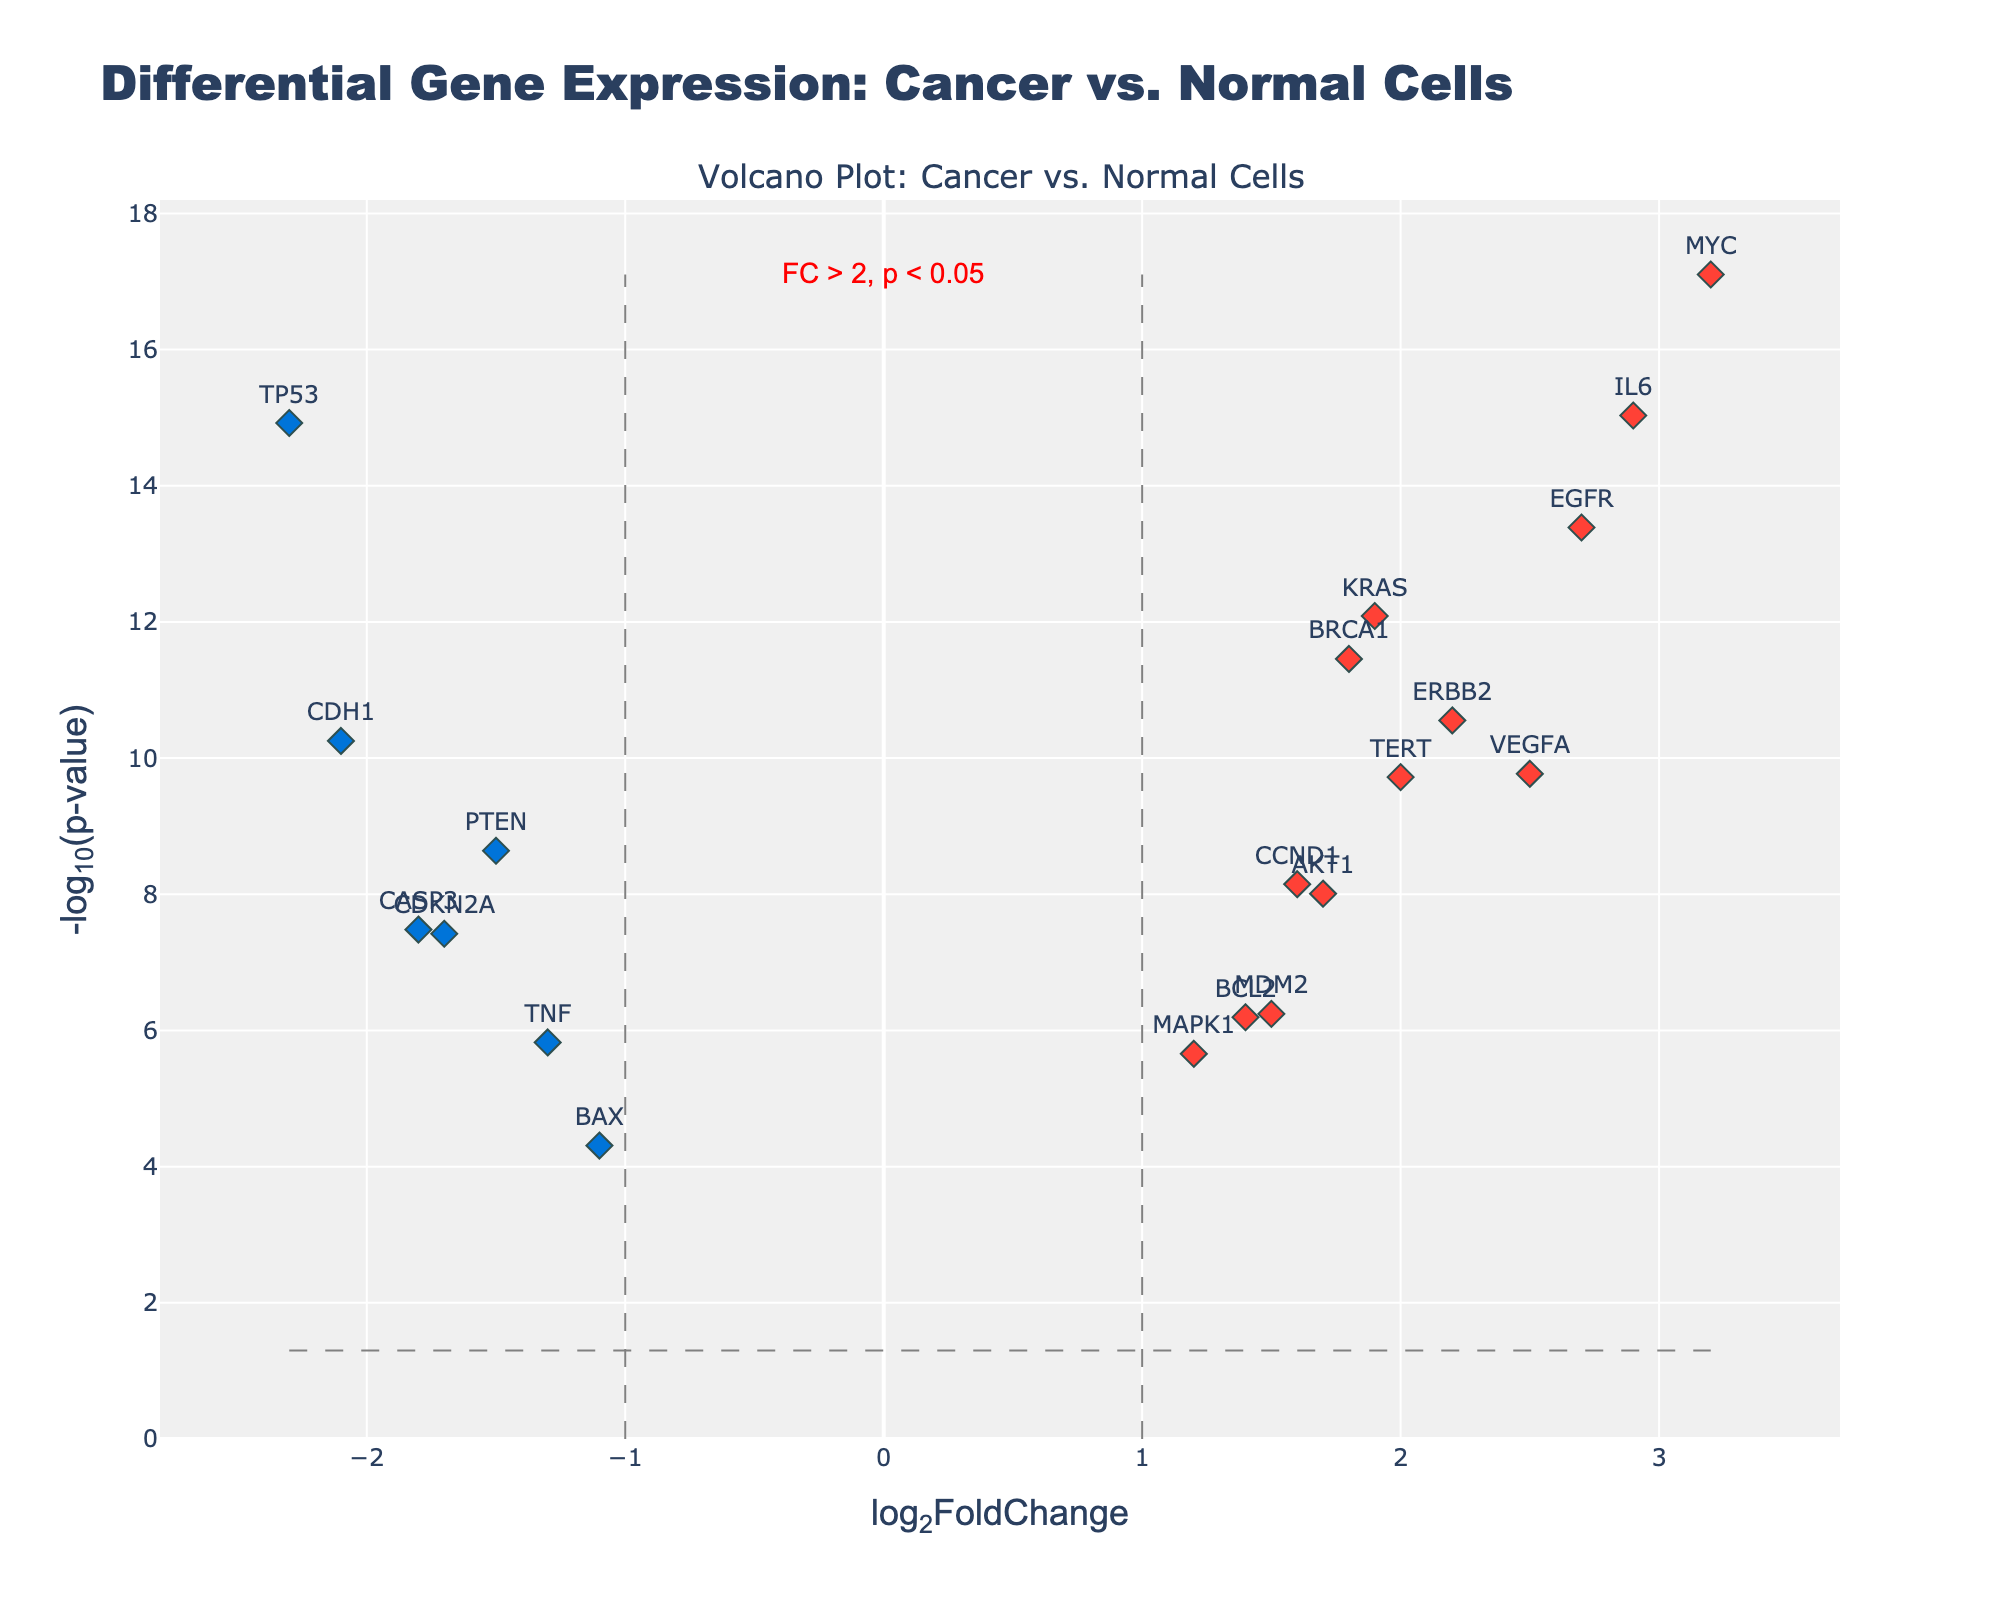What's the title of the plot? The title is displayed at the top of the plot and is usually meant to describe the contents of the figure.
Answer: Differential Gene Expression: Cancer vs. Normal Cells What does the x-axis represent? The information is provided at the bottom of the plot along the horizontal axis.
Answer: log2FoldChange How many genes are up-regulated? Count the number of data points that are colored red (up-regulated) in the plot.
Answer: 10 What is the significance threshold for the p-value? There's a dashed horizontal line at a particular y-value, which signifies the p-value threshold. This threshold corresponds to a -log10(p-value) value on the x-axis.
Answer: 0.05 Which gene has the highest -log10(p-value)? Identify the data point that is the highest on the y-axis and refer to its corresponding label.
Answer: MYC How many genes are considered significantly differentially expressed (both up- and down-regulated)? Count the number of data points that are either red or blue, as they indicate significant changes.
Answer: 18 What is the log2FoldChange threshold used in the plot to identify significant changes? Identify the vertical dashed lines on the plot that indicate the threshold for log2FoldChange.
Answer: ±1 Which gene has the lowest log2FoldChange among the significantly down-regulated genes? Look for the blue-colored data point furthest left on the x-axis.
Answer: TP53 What's the p-value of the gene EGFR? Hover over or refer to the hover text of the EGFR data point in the plot to find the p-value.
Answer: 4.1e-14 Compare the log2FoldChange of TERT and CDKN2A. Which one is higher? Locate both genes on the x-axis and compare their corresponding log2FoldChange values.
Answer: TERT 